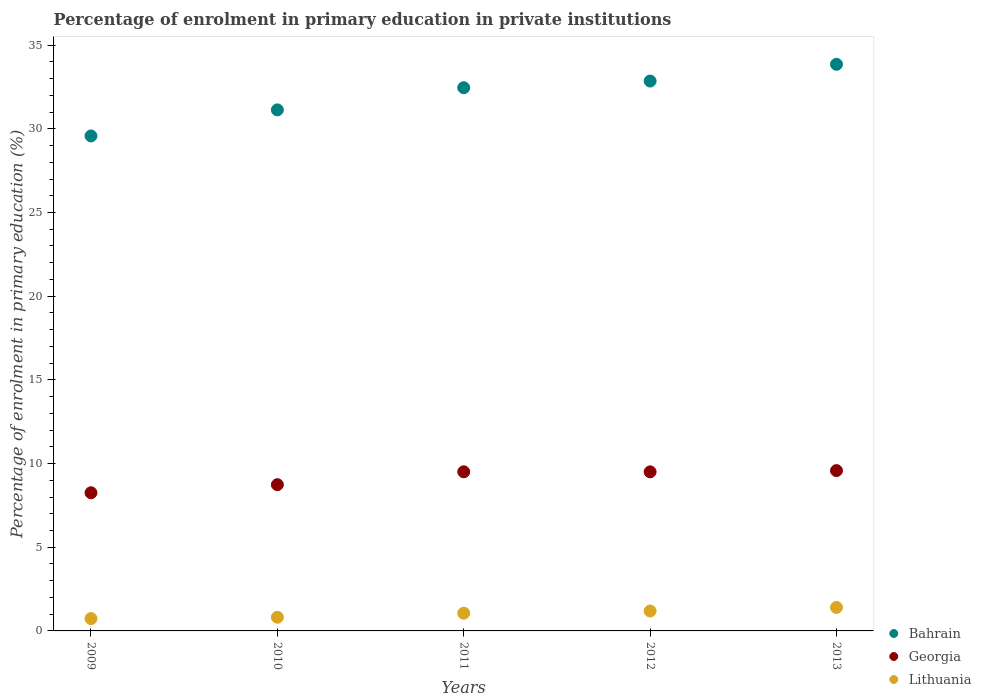What is the percentage of enrolment in primary education in Bahrain in 2013?
Make the answer very short. 33.85. Across all years, what is the maximum percentage of enrolment in primary education in Lithuania?
Keep it short and to the point. 1.4. Across all years, what is the minimum percentage of enrolment in primary education in Bahrain?
Offer a terse response. 29.57. What is the total percentage of enrolment in primary education in Georgia in the graph?
Your answer should be very brief. 45.58. What is the difference between the percentage of enrolment in primary education in Georgia in 2010 and that in 2012?
Your answer should be very brief. -0.77. What is the difference between the percentage of enrolment in primary education in Lithuania in 2011 and the percentage of enrolment in primary education in Georgia in 2013?
Provide a short and direct response. -8.52. What is the average percentage of enrolment in primary education in Lithuania per year?
Your answer should be compact. 1.04. In the year 2013, what is the difference between the percentage of enrolment in primary education in Georgia and percentage of enrolment in primary education in Lithuania?
Make the answer very short. 8.18. What is the ratio of the percentage of enrolment in primary education in Georgia in 2011 to that in 2013?
Offer a terse response. 0.99. Is the difference between the percentage of enrolment in primary education in Georgia in 2010 and 2012 greater than the difference between the percentage of enrolment in primary education in Lithuania in 2010 and 2012?
Provide a succinct answer. No. What is the difference between the highest and the second highest percentage of enrolment in primary education in Bahrain?
Provide a short and direct response. 1. What is the difference between the highest and the lowest percentage of enrolment in primary education in Lithuania?
Your answer should be compact. 0.67. Does the percentage of enrolment in primary education in Bahrain monotonically increase over the years?
Your answer should be compact. Yes. Is the percentage of enrolment in primary education in Bahrain strictly greater than the percentage of enrolment in primary education in Lithuania over the years?
Your response must be concise. Yes. How many dotlines are there?
Give a very brief answer. 3. Does the graph contain any zero values?
Make the answer very short. No. Where does the legend appear in the graph?
Offer a terse response. Bottom right. How many legend labels are there?
Provide a short and direct response. 3. How are the legend labels stacked?
Provide a succinct answer. Vertical. What is the title of the graph?
Provide a succinct answer. Percentage of enrolment in primary education in private institutions. What is the label or title of the X-axis?
Your response must be concise. Years. What is the label or title of the Y-axis?
Make the answer very short. Percentage of enrolment in primary education (%). What is the Percentage of enrolment in primary education (%) in Bahrain in 2009?
Keep it short and to the point. 29.57. What is the Percentage of enrolment in primary education (%) in Georgia in 2009?
Make the answer very short. 8.25. What is the Percentage of enrolment in primary education (%) in Lithuania in 2009?
Your answer should be very brief. 0.74. What is the Percentage of enrolment in primary education (%) of Bahrain in 2010?
Ensure brevity in your answer.  31.13. What is the Percentage of enrolment in primary education (%) of Georgia in 2010?
Make the answer very short. 8.74. What is the Percentage of enrolment in primary education (%) in Lithuania in 2010?
Keep it short and to the point. 0.82. What is the Percentage of enrolment in primary education (%) in Bahrain in 2011?
Your answer should be compact. 32.46. What is the Percentage of enrolment in primary education (%) in Georgia in 2011?
Offer a terse response. 9.51. What is the Percentage of enrolment in primary education (%) of Lithuania in 2011?
Make the answer very short. 1.06. What is the Percentage of enrolment in primary education (%) of Bahrain in 2012?
Provide a succinct answer. 32.85. What is the Percentage of enrolment in primary education (%) of Georgia in 2012?
Your response must be concise. 9.5. What is the Percentage of enrolment in primary education (%) of Lithuania in 2012?
Provide a short and direct response. 1.19. What is the Percentage of enrolment in primary education (%) of Bahrain in 2013?
Give a very brief answer. 33.85. What is the Percentage of enrolment in primary education (%) in Georgia in 2013?
Keep it short and to the point. 9.58. What is the Percentage of enrolment in primary education (%) in Lithuania in 2013?
Make the answer very short. 1.4. Across all years, what is the maximum Percentage of enrolment in primary education (%) in Bahrain?
Provide a short and direct response. 33.85. Across all years, what is the maximum Percentage of enrolment in primary education (%) in Georgia?
Give a very brief answer. 9.58. Across all years, what is the maximum Percentage of enrolment in primary education (%) of Lithuania?
Ensure brevity in your answer.  1.4. Across all years, what is the minimum Percentage of enrolment in primary education (%) in Bahrain?
Provide a short and direct response. 29.57. Across all years, what is the minimum Percentage of enrolment in primary education (%) of Georgia?
Provide a short and direct response. 8.25. Across all years, what is the minimum Percentage of enrolment in primary education (%) of Lithuania?
Your answer should be very brief. 0.74. What is the total Percentage of enrolment in primary education (%) of Bahrain in the graph?
Ensure brevity in your answer.  159.87. What is the total Percentage of enrolment in primary education (%) in Georgia in the graph?
Ensure brevity in your answer.  45.58. What is the total Percentage of enrolment in primary education (%) of Lithuania in the graph?
Keep it short and to the point. 5.21. What is the difference between the Percentage of enrolment in primary education (%) of Bahrain in 2009 and that in 2010?
Your answer should be very brief. -1.56. What is the difference between the Percentage of enrolment in primary education (%) of Georgia in 2009 and that in 2010?
Your response must be concise. -0.48. What is the difference between the Percentage of enrolment in primary education (%) in Lithuania in 2009 and that in 2010?
Provide a short and direct response. -0.08. What is the difference between the Percentage of enrolment in primary education (%) of Bahrain in 2009 and that in 2011?
Provide a short and direct response. -2.88. What is the difference between the Percentage of enrolment in primary education (%) of Georgia in 2009 and that in 2011?
Offer a very short reply. -1.25. What is the difference between the Percentage of enrolment in primary education (%) of Lithuania in 2009 and that in 2011?
Ensure brevity in your answer.  -0.32. What is the difference between the Percentage of enrolment in primary education (%) of Bahrain in 2009 and that in 2012?
Keep it short and to the point. -3.28. What is the difference between the Percentage of enrolment in primary education (%) in Georgia in 2009 and that in 2012?
Ensure brevity in your answer.  -1.25. What is the difference between the Percentage of enrolment in primary education (%) in Lithuania in 2009 and that in 2012?
Your response must be concise. -0.45. What is the difference between the Percentage of enrolment in primary education (%) of Bahrain in 2009 and that in 2013?
Your answer should be very brief. -4.28. What is the difference between the Percentage of enrolment in primary education (%) of Georgia in 2009 and that in 2013?
Provide a short and direct response. -1.32. What is the difference between the Percentage of enrolment in primary education (%) in Lithuania in 2009 and that in 2013?
Your answer should be very brief. -0.67. What is the difference between the Percentage of enrolment in primary education (%) of Bahrain in 2010 and that in 2011?
Give a very brief answer. -1.33. What is the difference between the Percentage of enrolment in primary education (%) of Georgia in 2010 and that in 2011?
Provide a succinct answer. -0.77. What is the difference between the Percentage of enrolment in primary education (%) of Lithuania in 2010 and that in 2011?
Provide a succinct answer. -0.24. What is the difference between the Percentage of enrolment in primary education (%) in Bahrain in 2010 and that in 2012?
Provide a succinct answer. -1.72. What is the difference between the Percentage of enrolment in primary education (%) of Georgia in 2010 and that in 2012?
Provide a short and direct response. -0.77. What is the difference between the Percentage of enrolment in primary education (%) in Lithuania in 2010 and that in 2012?
Provide a succinct answer. -0.37. What is the difference between the Percentage of enrolment in primary education (%) of Bahrain in 2010 and that in 2013?
Offer a very short reply. -2.72. What is the difference between the Percentage of enrolment in primary education (%) of Georgia in 2010 and that in 2013?
Ensure brevity in your answer.  -0.84. What is the difference between the Percentage of enrolment in primary education (%) of Lithuania in 2010 and that in 2013?
Your answer should be compact. -0.59. What is the difference between the Percentage of enrolment in primary education (%) of Bahrain in 2011 and that in 2012?
Ensure brevity in your answer.  -0.4. What is the difference between the Percentage of enrolment in primary education (%) in Georgia in 2011 and that in 2012?
Provide a short and direct response. 0. What is the difference between the Percentage of enrolment in primary education (%) of Lithuania in 2011 and that in 2012?
Offer a very short reply. -0.13. What is the difference between the Percentage of enrolment in primary education (%) of Bahrain in 2011 and that in 2013?
Make the answer very short. -1.4. What is the difference between the Percentage of enrolment in primary education (%) in Georgia in 2011 and that in 2013?
Make the answer very short. -0.07. What is the difference between the Percentage of enrolment in primary education (%) of Lithuania in 2011 and that in 2013?
Keep it short and to the point. -0.34. What is the difference between the Percentage of enrolment in primary education (%) of Bahrain in 2012 and that in 2013?
Make the answer very short. -1. What is the difference between the Percentage of enrolment in primary education (%) of Georgia in 2012 and that in 2013?
Your answer should be compact. -0.07. What is the difference between the Percentage of enrolment in primary education (%) of Lithuania in 2012 and that in 2013?
Give a very brief answer. -0.21. What is the difference between the Percentage of enrolment in primary education (%) of Bahrain in 2009 and the Percentage of enrolment in primary education (%) of Georgia in 2010?
Keep it short and to the point. 20.84. What is the difference between the Percentage of enrolment in primary education (%) of Bahrain in 2009 and the Percentage of enrolment in primary education (%) of Lithuania in 2010?
Your answer should be very brief. 28.76. What is the difference between the Percentage of enrolment in primary education (%) in Georgia in 2009 and the Percentage of enrolment in primary education (%) in Lithuania in 2010?
Your answer should be compact. 7.44. What is the difference between the Percentage of enrolment in primary education (%) in Bahrain in 2009 and the Percentage of enrolment in primary education (%) in Georgia in 2011?
Offer a very short reply. 20.07. What is the difference between the Percentage of enrolment in primary education (%) in Bahrain in 2009 and the Percentage of enrolment in primary education (%) in Lithuania in 2011?
Provide a short and direct response. 28.52. What is the difference between the Percentage of enrolment in primary education (%) in Georgia in 2009 and the Percentage of enrolment in primary education (%) in Lithuania in 2011?
Your response must be concise. 7.2. What is the difference between the Percentage of enrolment in primary education (%) of Bahrain in 2009 and the Percentage of enrolment in primary education (%) of Georgia in 2012?
Your answer should be very brief. 20.07. What is the difference between the Percentage of enrolment in primary education (%) of Bahrain in 2009 and the Percentage of enrolment in primary education (%) of Lithuania in 2012?
Offer a very short reply. 28.39. What is the difference between the Percentage of enrolment in primary education (%) in Georgia in 2009 and the Percentage of enrolment in primary education (%) in Lithuania in 2012?
Offer a terse response. 7.07. What is the difference between the Percentage of enrolment in primary education (%) of Bahrain in 2009 and the Percentage of enrolment in primary education (%) of Georgia in 2013?
Your answer should be very brief. 20. What is the difference between the Percentage of enrolment in primary education (%) of Bahrain in 2009 and the Percentage of enrolment in primary education (%) of Lithuania in 2013?
Keep it short and to the point. 28.17. What is the difference between the Percentage of enrolment in primary education (%) of Georgia in 2009 and the Percentage of enrolment in primary education (%) of Lithuania in 2013?
Ensure brevity in your answer.  6.85. What is the difference between the Percentage of enrolment in primary education (%) in Bahrain in 2010 and the Percentage of enrolment in primary education (%) in Georgia in 2011?
Your answer should be very brief. 21.62. What is the difference between the Percentage of enrolment in primary education (%) of Bahrain in 2010 and the Percentage of enrolment in primary education (%) of Lithuania in 2011?
Provide a short and direct response. 30.07. What is the difference between the Percentage of enrolment in primary education (%) of Georgia in 2010 and the Percentage of enrolment in primary education (%) of Lithuania in 2011?
Provide a succinct answer. 7.68. What is the difference between the Percentage of enrolment in primary education (%) of Bahrain in 2010 and the Percentage of enrolment in primary education (%) of Georgia in 2012?
Keep it short and to the point. 21.63. What is the difference between the Percentage of enrolment in primary education (%) in Bahrain in 2010 and the Percentage of enrolment in primary education (%) in Lithuania in 2012?
Offer a terse response. 29.94. What is the difference between the Percentage of enrolment in primary education (%) in Georgia in 2010 and the Percentage of enrolment in primary education (%) in Lithuania in 2012?
Make the answer very short. 7.55. What is the difference between the Percentage of enrolment in primary education (%) of Bahrain in 2010 and the Percentage of enrolment in primary education (%) of Georgia in 2013?
Provide a succinct answer. 21.55. What is the difference between the Percentage of enrolment in primary education (%) of Bahrain in 2010 and the Percentage of enrolment in primary education (%) of Lithuania in 2013?
Ensure brevity in your answer.  29.73. What is the difference between the Percentage of enrolment in primary education (%) in Georgia in 2010 and the Percentage of enrolment in primary education (%) in Lithuania in 2013?
Ensure brevity in your answer.  7.33. What is the difference between the Percentage of enrolment in primary education (%) in Bahrain in 2011 and the Percentage of enrolment in primary education (%) in Georgia in 2012?
Give a very brief answer. 22.95. What is the difference between the Percentage of enrolment in primary education (%) in Bahrain in 2011 and the Percentage of enrolment in primary education (%) in Lithuania in 2012?
Offer a terse response. 31.27. What is the difference between the Percentage of enrolment in primary education (%) of Georgia in 2011 and the Percentage of enrolment in primary education (%) of Lithuania in 2012?
Your response must be concise. 8.32. What is the difference between the Percentage of enrolment in primary education (%) in Bahrain in 2011 and the Percentage of enrolment in primary education (%) in Georgia in 2013?
Provide a short and direct response. 22.88. What is the difference between the Percentage of enrolment in primary education (%) in Bahrain in 2011 and the Percentage of enrolment in primary education (%) in Lithuania in 2013?
Give a very brief answer. 31.05. What is the difference between the Percentage of enrolment in primary education (%) in Georgia in 2011 and the Percentage of enrolment in primary education (%) in Lithuania in 2013?
Make the answer very short. 8.1. What is the difference between the Percentage of enrolment in primary education (%) in Bahrain in 2012 and the Percentage of enrolment in primary education (%) in Georgia in 2013?
Your answer should be very brief. 23.28. What is the difference between the Percentage of enrolment in primary education (%) of Bahrain in 2012 and the Percentage of enrolment in primary education (%) of Lithuania in 2013?
Your response must be concise. 31.45. What is the difference between the Percentage of enrolment in primary education (%) of Georgia in 2012 and the Percentage of enrolment in primary education (%) of Lithuania in 2013?
Your answer should be compact. 8.1. What is the average Percentage of enrolment in primary education (%) of Bahrain per year?
Provide a succinct answer. 31.97. What is the average Percentage of enrolment in primary education (%) of Georgia per year?
Make the answer very short. 9.12. What is the average Percentage of enrolment in primary education (%) of Lithuania per year?
Your response must be concise. 1.04. In the year 2009, what is the difference between the Percentage of enrolment in primary education (%) of Bahrain and Percentage of enrolment in primary education (%) of Georgia?
Your answer should be compact. 21.32. In the year 2009, what is the difference between the Percentage of enrolment in primary education (%) in Bahrain and Percentage of enrolment in primary education (%) in Lithuania?
Make the answer very short. 28.84. In the year 2009, what is the difference between the Percentage of enrolment in primary education (%) of Georgia and Percentage of enrolment in primary education (%) of Lithuania?
Offer a very short reply. 7.52. In the year 2010, what is the difference between the Percentage of enrolment in primary education (%) in Bahrain and Percentage of enrolment in primary education (%) in Georgia?
Offer a very short reply. 22.39. In the year 2010, what is the difference between the Percentage of enrolment in primary education (%) of Bahrain and Percentage of enrolment in primary education (%) of Lithuania?
Provide a succinct answer. 30.31. In the year 2010, what is the difference between the Percentage of enrolment in primary education (%) of Georgia and Percentage of enrolment in primary education (%) of Lithuania?
Your answer should be very brief. 7.92. In the year 2011, what is the difference between the Percentage of enrolment in primary education (%) in Bahrain and Percentage of enrolment in primary education (%) in Georgia?
Your answer should be compact. 22.95. In the year 2011, what is the difference between the Percentage of enrolment in primary education (%) of Bahrain and Percentage of enrolment in primary education (%) of Lithuania?
Provide a succinct answer. 31.4. In the year 2011, what is the difference between the Percentage of enrolment in primary education (%) in Georgia and Percentage of enrolment in primary education (%) in Lithuania?
Your answer should be compact. 8.45. In the year 2012, what is the difference between the Percentage of enrolment in primary education (%) of Bahrain and Percentage of enrolment in primary education (%) of Georgia?
Give a very brief answer. 23.35. In the year 2012, what is the difference between the Percentage of enrolment in primary education (%) in Bahrain and Percentage of enrolment in primary education (%) in Lithuania?
Provide a succinct answer. 31.66. In the year 2012, what is the difference between the Percentage of enrolment in primary education (%) of Georgia and Percentage of enrolment in primary education (%) of Lithuania?
Make the answer very short. 8.31. In the year 2013, what is the difference between the Percentage of enrolment in primary education (%) of Bahrain and Percentage of enrolment in primary education (%) of Georgia?
Your answer should be compact. 24.28. In the year 2013, what is the difference between the Percentage of enrolment in primary education (%) in Bahrain and Percentage of enrolment in primary education (%) in Lithuania?
Provide a short and direct response. 32.45. In the year 2013, what is the difference between the Percentage of enrolment in primary education (%) of Georgia and Percentage of enrolment in primary education (%) of Lithuania?
Provide a succinct answer. 8.18. What is the ratio of the Percentage of enrolment in primary education (%) in Bahrain in 2009 to that in 2010?
Offer a very short reply. 0.95. What is the ratio of the Percentage of enrolment in primary education (%) in Georgia in 2009 to that in 2010?
Provide a short and direct response. 0.94. What is the ratio of the Percentage of enrolment in primary education (%) of Lithuania in 2009 to that in 2010?
Provide a short and direct response. 0.9. What is the ratio of the Percentage of enrolment in primary education (%) in Bahrain in 2009 to that in 2011?
Provide a succinct answer. 0.91. What is the ratio of the Percentage of enrolment in primary education (%) of Georgia in 2009 to that in 2011?
Keep it short and to the point. 0.87. What is the ratio of the Percentage of enrolment in primary education (%) in Lithuania in 2009 to that in 2011?
Your answer should be compact. 0.7. What is the ratio of the Percentage of enrolment in primary education (%) of Bahrain in 2009 to that in 2012?
Provide a short and direct response. 0.9. What is the ratio of the Percentage of enrolment in primary education (%) of Georgia in 2009 to that in 2012?
Ensure brevity in your answer.  0.87. What is the ratio of the Percentage of enrolment in primary education (%) of Lithuania in 2009 to that in 2012?
Make the answer very short. 0.62. What is the ratio of the Percentage of enrolment in primary education (%) of Bahrain in 2009 to that in 2013?
Keep it short and to the point. 0.87. What is the ratio of the Percentage of enrolment in primary education (%) of Georgia in 2009 to that in 2013?
Provide a succinct answer. 0.86. What is the ratio of the Percentage of enrolment in primary education (%) in Lithuania in 2009 to that in 2013?
Offer a very short reply. 0.53. What is the ratio of the Percentage of enrolment in primary education (%) of Bahrain in 2010 to that in 2011?
Offer a very short reply. 0.96. What is the ratio of the Percentage of enrolment in primary education (%) of Georgia in 2010 to that in 2011?
Provide a succinct answer. 0.92. What is the ratio of the Percentage of enrolment in primary education (%) of Lithuania in 2010 to that in 2011?
Ensure brevity in your answer.  0.77. What is the ratio of the Percentage of enrolment in primary education (%) in Bahrain in 2010 to that in 2012?
Provide a short and direct response. 0.95. What is the ratio of the Percentage of enrolment in primary education (%) of Georgia in 2010 to that in 2012?
Make the answer very short. 0.92. What is the ratio of the Percentage of enrolment in primary education (%) in Lithuania in 2010 to that in 2012?
Offer a very short reply. 0.69. What is the ratio of the Percentage of enrolment in primary education (%) of Bahrain in 2010 to that in 2013?
Provide a short and direct response. 0.92. What is the ratio of the Percentage of enrolment in primary education (%) in Georgia in 2010 to that in 2013?
Provide a short and direct response. 0.91. What is the ratio of the Percentage of enrolment in primary education (%) in Lithuania in 2010 to that in 2013?
Offer a terse response. 0.58. What is the ratio of the Percentage of enrolment in primary education (%) in Bahrain in 2011 to that in 2012?
Give a very brief answer. 0.99. What is the ratio of the Percentage of enrolment in primary education (%) in Lithuania in 2011 to that in 2012?
Offer a terse response. 0.89. What is the ratio of the Percentage of enrolment in primary education (%) of Bahrain in 2011 to that in 2013?
Offer a terse response. 0.96. What is the ratio of the Percentage of enrolment in primary education (%) in Georgia in 2011 to that in 2013?
Provide a short and direct response. 0.99. What is the ratio of the Percentage of enrolment in primary education (%) in Lithuania in 2011 to that in 2013?
Offer a terse response. 0.76. What is the ratio of the Percentage of enrolment in primary education (%) of Bahrain in 2012 to that in 2013?
Ensure brevity in your answer.  0.97. What is the ratio of the Percentage of enrolment in primary education (%) in Georgia in 2012 to that in 2013?
Keep it short and to the point. 0.99. What is the ratio of the Percentage of enrolment in primary education (%) of Lithuania in 2012 to that in 2013?
Offer a terse response. 0.85. What is the difference between the highest and the second highest Percentage of enrolment in primary education (%) of Georgia?
Your answer should be very brief. 0.07. What is the difference between the highest and the second highest Percentage of enrolment in primary education (%) of Lithuania?
Make the answer very short. 0.21. What is the difference between the highest and the lowest Percentage of enrolment in primary education (%) of Bahrain?
Offer a terse response. 4.28. What is the difference between the highest and the lowest Percentage of enrolment in primary education (%) of Georgia?
Offer a terse response. 1.32. What is the difference between the highest and the lowest Percentage of enrolment in primary education (%) of Lithuania?
Your response must be concise. 0.67. 